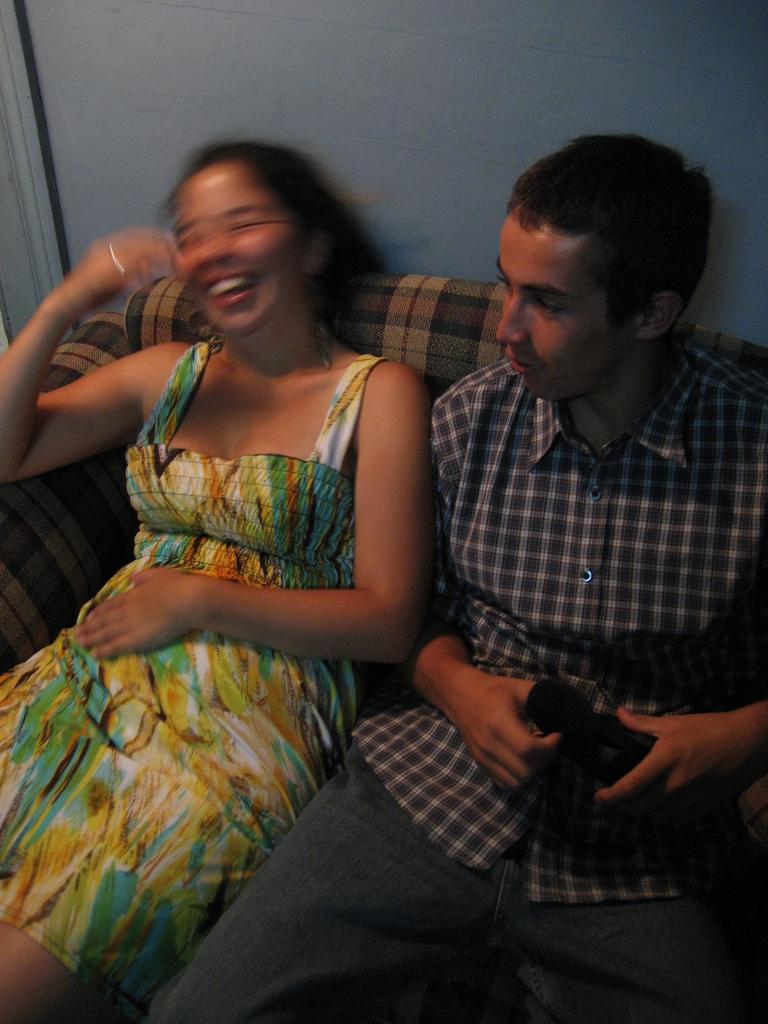How many people are sitting on the sofa in the image? There are two persons sitting on a sofa in the image. What is the person holding in the image? There is a person holding an object in the image. What can be seen in the background of the image? There is a wall in the background of the image. What time of day is it in the image, given the presence of an icicle? There is no icicle present in the image, so it cannot be determined what time of day it is based on that information. 